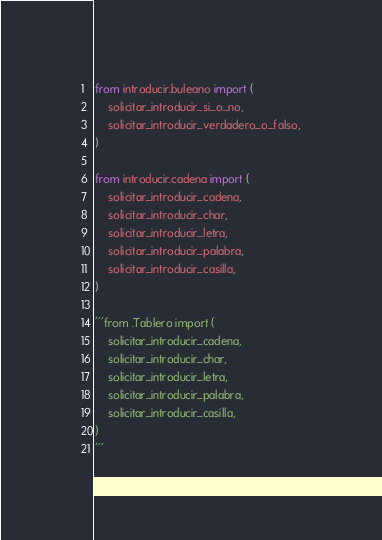Convert code to text. <code><loc_0><loc_0><loc_500><loc_500><_Python_>
from introducir.buleano import (
    solicitar_introducir_si_o_no,
    solicitar_introducir_verdadero_o_falso,
)

from introducir.cadena import (
    solicitar_introducir_cadena,
    solicitar_introducir_char,
    solicitar_introducir_letra,
    solicitar_introducir_palabra,
    solicitar_introducir_casilla,
)

'''from .Tablero import (
    solicitar_introducir_cadena,
    solicitar_introducir_char,
    solicitar_introducir_letra,
    solicitar_introducir_palabra,
    solicitar_introducir_casilla,
)
'''</code> 